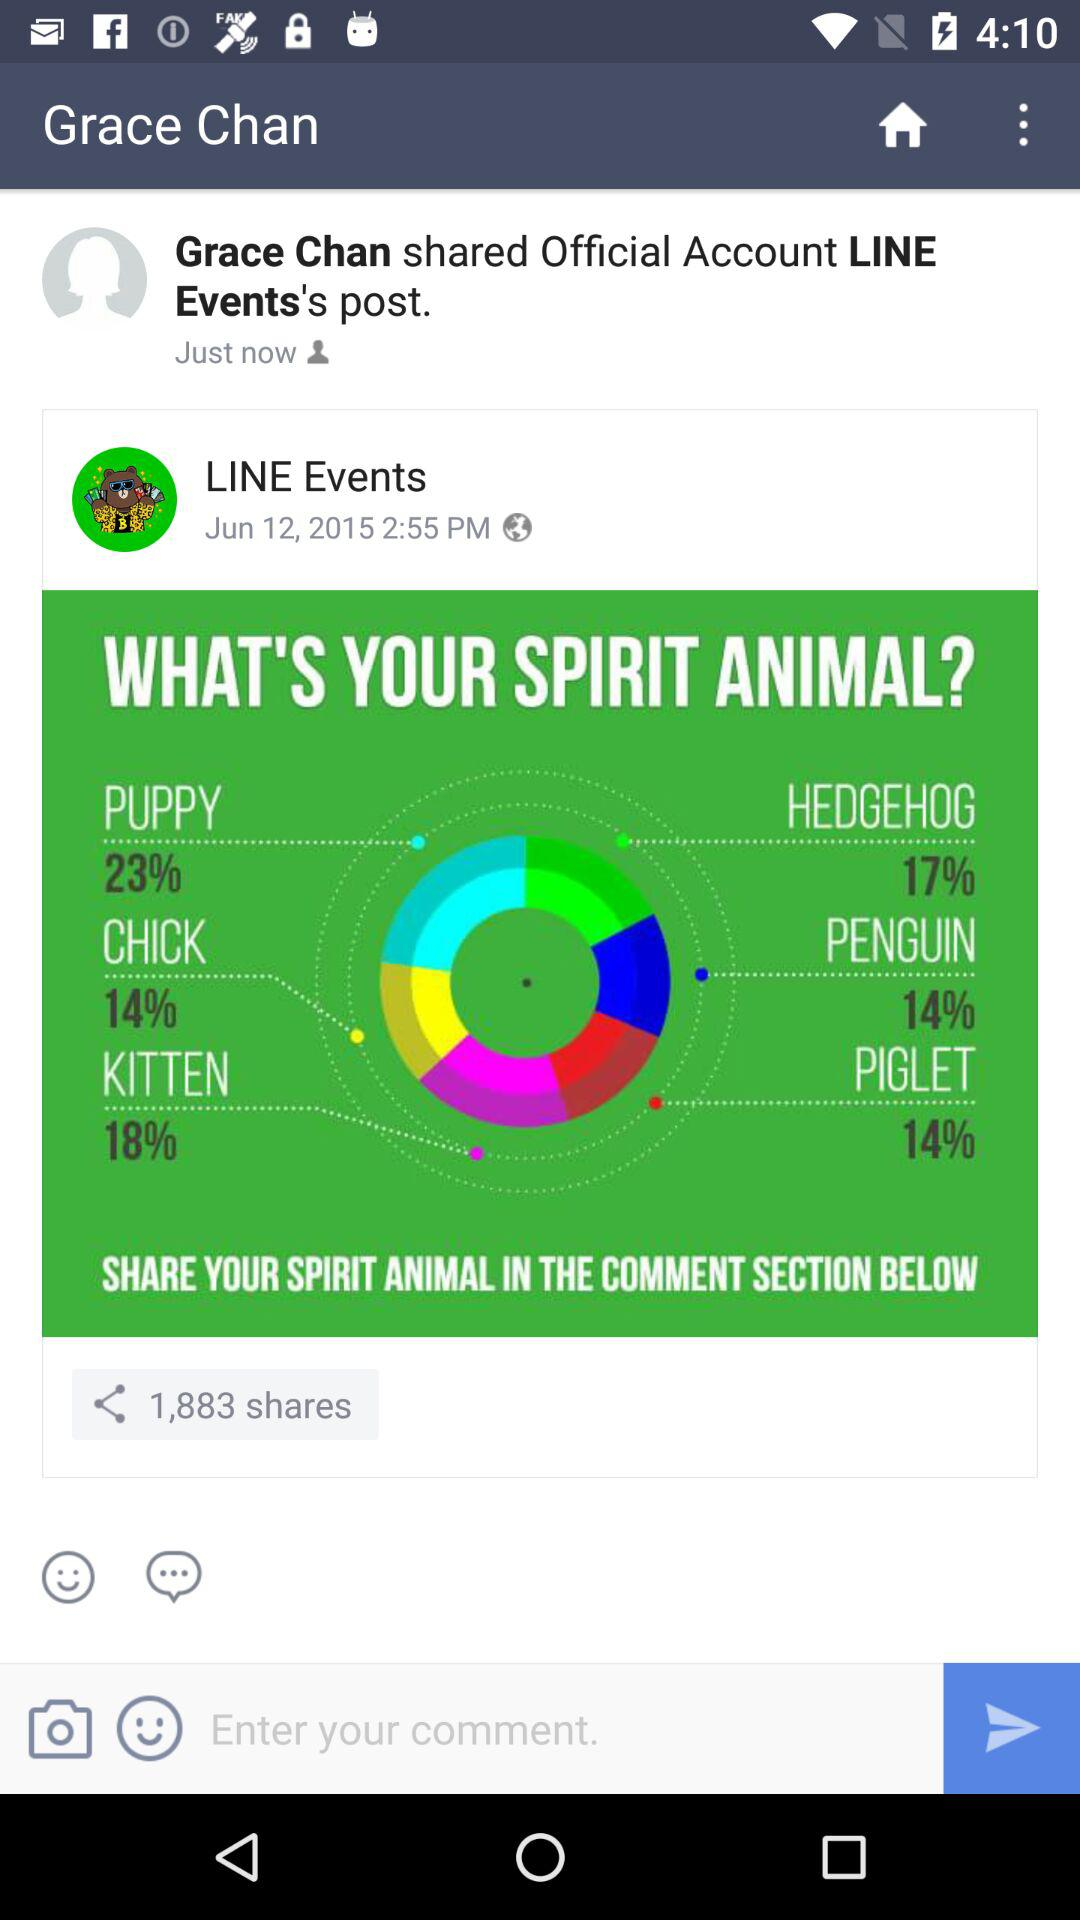What's the posted date and time of the post by "LINE Events"? The posted date is June 12, 2015 and the time is 2:55 p.m. 